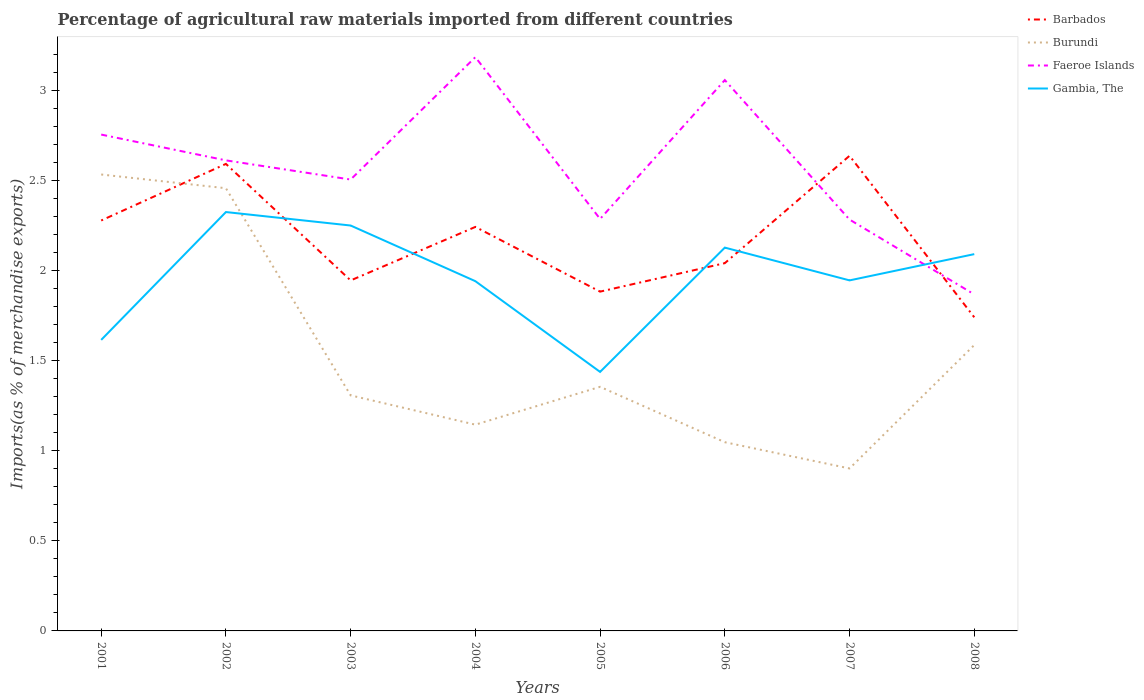Does the line corresponding to Barbados intersect with the line corresponding to Faeroe Islands?
Give a very brief answer. Yes. Is the number of lines equal to the number of legend labels?
Offer a very short reply. Yes. Across all years, what is the maximum percentage of imports to different countries in Burundi?
Your response must be concise. 0.9. What is the total percentage of imports to different countries in Gambia, The in the graph?
Ensure brevity in your answer.  -0.19. What is the difference between the highest and the second highest percentage of imports to different countries in Gambia, The?
Your answer should be very brief. 0.89. Is the percentage of imports to different countries in Faeroe Islands strictly greater than the percentage of imports to different countries in Barbados over the years?
Your response must be concise. No. How many lines are there?
Your answer should be very brief. 4. How many years are there in the graph?
Your response must be concise. 8. Are the values on the major ticks of Y-axis written in scientific E-notation?
Provide a short and direct response. No. Does the graph contain any zero values?
Provide a succinct answer. No. Does the graph contain grids?
Your answer should be very brief. No. How are the legend labels stacked?
Keep it short and to the point. Vertical. What is the title of the graph?
Ensure brevity in your answer.  Percentage of agricultural raw materials imported from different countries. What is the label or title of the X-axis?
Provide a succinct answer. Years. What is the label or title of the Y-axis?
Give a very brief answer. Imports(as % of merchandise exports). What is the Imports(as % of merchandise exports) in Barbados in 2001?
Make the answer very short. 2.28. What is the Imports(as % of merchandise exports) in Burundi in 2001?
Your response must be concise. 2.53. What is the Imports(as % of merchandise exports) of Faeroe Islands in 2001?
Keep it short and to the point. 2.75. What is the Imports(as % of merchandise exports) in Gambia, The in 2001?
Offer a terse response. 1.61. What is the Imports(as % of merchandise exports) in Barbados in 2002?
Offer a very short reply. 2.59. What is the Imports(as % of merchandise exports) in Burundi in 2002?
Make the answer very short. 2.46. What is the Imports(as % of merchandise exports) in Faeroe Islands in 2002?
Offer a very short reply. 2.61. What is the Imports(as % of merchandise exports) of Gambia, The in 2002?
Make the answer very short. 2.32. What is the Imports(as % of merchandise exports) of Barbados in 2003?
Provide a succinct answer. 1.94. What is the Imports(as % of merchandise exports) of Burundi in 2003?
Keep it short and to the point. 1.31. What is the Imports(as % of merchandise exports) in Faeroe Islands in 2003?
Your answer should be compact. 2.5. What is the Imports(as % of merchandise exports) of Gambia, The in 2003?
Your answer should be compact. 2.25. What is the Imports(as % of merchandise exports) of Barbados in 2004?
Provide a short and direct response. 2.24. What is the Imports(as % of merchandise exports) in Burundi in 2004?
Provide a succinct answer. 1.14. What is the Imports(as % of merchandise exports) in Faeroe Islands in 2004?
Your answer should be very brief. 3.18. What is the Imports(as % of merchandise exports) of Gambia, The in 2004?
Provide a succinct answer. 1.94. What is the Imports(as % of merchandise exports) of Barbados in 2005?
Ensure brevity in your answer.  1.88. What is the Imports(as % of merchandise exports) of Burundi in 2005?
Give a very brief answer. 1.35. What is the Imports(as % of merchandise exports) of Faeroe Islands in 2005?
Provide a succinct answer. 2.29. What is the Imports(as % of merchandise exports) of Gambia, The in 2005?
Offer a very short reply. 1.44. What is the Imports(as % of merchandise exports) of Barbados in 2006?
Your answer should be very brief. 2.04. What is the Imports(as % of merchandise exports) of Burundi in 2006?
Your answer should be compact. 1.05. What is the Imports(as % of merchandise exports) in Faeroe Islands in 2006?
Make the answer very short. 3.06. What is the Imports(as % of merchandise exports) of Gambia, The in 2006?
Provide a succinct answer. 2.13. What is the Imports(as % of merchandise exports) in Barbados in 2007?
Provide a short and direct response. 2.64. What is the Imports(as % of merchandise exports) of Burundi in 2007?
Offer a very short reply. 0.9. What is the Imports(as % of merchandise exports) in Faeroe Islands in 2007?
Keep it short and to the point. 2.28. What is the Imports(as % of merchandise exports) in Gambia, The in 2007?
Ensure brevity in your answer.  1.94. What is the Imports(as % of merchandise exports) in Barbados in 2008?
Keep it short and to the point. 1.74. What is the Imports(as % of merchandise exports) of Burundi in 2008?
Make the answer very short. 1.59. What is the Imports(as % of merchandise exports) in Faeroe Islands in 2008?
Provide a succinct answer. 1.87. What is the Imports(as % of merchandise exports) of Gambia, The in 2008?
Offer a very short reply. 2.09. Across all years, what is the maximum Imports(as % of merchandise exports) of Barbados?
Offer a very short reply. 2.64. Across all years, what is the maximum Imports(as % of merchandise exports) in Burundi?
Make the answer very short. 2.53. Across all years, what is the maximum Imports(as % of merchandise exports) in Faeroe Islands?
Your response must be concise. 3.18. Across all years, what is the maximum Imports(as % of merchandise exports) of Gambia, The?
Give a very brief answer. 2.32. Across all years, what is the minimum Imports(as % of merchandise exports) of Barbados?
Your response must be concise. 1.74. Across all years, what is the minimum Imports(as % of merchandise exports) in Burundi?
Ensure brevity in your answer.  0.9. Across all years, what is the minimum Imports(as % of merchandise exports) in Faeroe Islands?
Ensure brevity in your answer.  1.87. Across all years, what is the minimum Imports(as % of merchandise exports) of Gambia, The?
Your answer should be compact. 1.44. What is the total Imports(as % of merchandise exports) in Barbados in the graph?
Offer a terse response. 17.35. What is the total Imports(as % of merchandise exports) in Burundi in the graph?
Give a very brief answer. 12.33. What is the total Imports(as % of merchandise exports) of Faeroe Islands in the graph?
Offer a very short reply. 20.54. What is the total Imports(as % of merchandise exports) of Gambia, The in the graph?
Your response must be concise. 15.72. What is the difference between the Imports(as % of merchandise exports) of Barbados in 2001 and that in 2002?
Offer a terse response. -0.31. What is the difference between the Imports(as % of merchandise exports) in Burundi in 2001 and that in 2002?
Offer a terse response. 0.08. What is the difference between the Imports(as % of merchandise exports) of Faeroe Islands in 2001 and that in 2002?
Your answer should be very brief. 0.14. What is the difference between the Imports(as % of merchandise exports) in Gambia, The in 2001 and that in 2002?
Offer a very short reply. -0.71. What is the difference between the Imports(as % of merchandise exports) in Barbados in 2001 and that in 2003?
Make the answer very short. 0.33. What is the difference between the Imports(as % of merchandise exports) in Burundi in 2001 and that in 2003?
Your response must be concise. 1.23. What is the difference between the Imports(as % of merchandise exports) of Faeroe Islands in 2001 and that in 2003?
Provide a short and direct response. 0.25. What is the difference between the Imports(as % of merchandise exports) of Gambia, The in 2001 and that in 2003?
Provide a short and direct response. -0.63. What is the difference between the Imports(as % of merchandise exports) in Barbados in 2001 and that in 2004?
Your answer should be compact. 0.04. What is the difference between the Imports(as % of merchandise exports) in Burundi in 2001 and that in 2004?
Offer a terse response. 1.39. What is the difference between the Imports(as % of merchandise exports) in Faeroe Islands in 2001 and that in 2004?
Offer a terse response. -0.43. What is the difference between the Imports(as % of merchandise exports) in Gambia, The in 2001 and that in 2004?
Give a very brief answer. -0.33. What is the difference between the Imports(as % of merchandise exports) of Barbados in 2001 and that in 2005?
Give a very brief answer. 0.39. What is the difference between the Imports(as % of merchandise exports) of Burundi in 2001 and that in 2005?
Offer a very short reply. 1.18. What is the difference between the Imports(as % of merchandise exports) in Faeroe Islands in 2001 and that in 2005?
Give a very brief answer. 0.47. What is the difference between the Imports(as % of merchandise exports) of Gambia, The in 2001 and that in 2005?
Offer a very short reply. 0.18. What is the difference between the Imports(as % of merchandise exports) in Barbados in 2001 and that in 2006?
Offer a terse response. 0.24. What is the difference between the Imports(as % of merchandise exports) of Burundi in 2001 and that in 2006?
Your answer should be compact. 1.49. What is the difference between the Imports(as % of merchandise exports) of Faeroe Islands in 2001 and that in 2006?
Offer a terse response. -0.3. What is the difference between the Imports(as % of merchandise exports) of Gambia, The in 2001 and that in 2006?
Your response must be concise. -0.51. What is the difference between the Imports(as % of merchandise exports) of Barbados in 2001 and that in 2007?
Ensure brevity in your answer.  -0.36. What is the difference between the Imports(as % of merchandise exports) of Burundi in 2001 and that in 2007?
Provide a succinct answer. 1.63. What is the difference between the Imports(as % of merchandise exports) in Faeroe Islands in 2001 and that in 2007?
Your response must be concise. 0.47. What is the difference between the Imports(as % of merchandise exports) of Gambia, The in 2001 and that in 2007?
Ensure brevity in your answer.  -0.33. What is the difference between the Imports(as % of merchandise exports) of Barbados in 2001 and that in 2008?
Make the answer very short. 0.54. What is the difference between the Imports(as % of merchandise exports) in Burundi in 2001 and that in 2008?
Your answer should be compact. 0.95. What is the difference between the Imports(as % of merchandise exports) in Faeroe Islands in 2001 and that in 2008?
Keep it short and to the point. 0.89. What is the difference between the Imports(as % of merchandise exports) of Gambia, The in 2001 and that in 2008?
Provide a short and direct response. -0.48. What is the difference between the Imports(as % of merchandise exports) in Barbados in 2002 and that in 2003?
Ensure brevity in your answer.  0.65. What is the difference between the Imports(as % of merchandise exports) in Burundi in 2002 and that in 2003?
Make the answer very short. 1.15. What is the difference between the Imports(as % of merchandise exports) in Faeroe Islands in 2002 and that in 2003?
Your answer should be compact. 0.11. What is the difference between the Imports(as % of merchandise exports) of Gambia, The in 2002 and that in 2003?
Your response must be concise. 0.07. What is the difference between the Imports(as % of merchandise exports) in Barbados in 2002 and that in 2004?
Make the answer very short. 0.35. What is the difference between the Imports(as % of merchandise exports) in Burundi in 2002 and that in 2004?
Your response must be concise. 1.31. What is the difference between the Imports(as % of merchandise exports) of Faeroe Islands in 2002 and that in 2004?
Keep it short and to the point. -0.57. What is the difference between the Imports(as % of merchandise exports) of Gambia, The in 2002 and that in 2004?
Your answer should be very brief. 0.38. What is the difference between the Imports(as % of merchandise exports) of Barbados in 2002 and that in 2005?
Give a very brief answer. 0.71. What is the difference between the Imports(as % of merchandise exports) of Burundi in 2002 and that in 2005?
Provide a short and direct response. 1.1. What is the difference between the Imports(as % of merchandise exports) of Faeroe Islands in 2002 and that in 2005?
Make the answer very short. 0.32. What is the difference between the Imports(as % of merchandise exports) of Gambia, The in 2002 and that in 2005?
Offer a terse response. 0.89. What is the difference between the Imports(as % of merchandise exports) in Barbados in 2002 and that in 2006?
Your response must be concise. 0.55. What is the difference between the Imports(as % of merchandise exports) of Burundi in 2002 and that in 2006?
Ensure brevity in your answer.  1.41. What is the difference between the Imports(as % of merchandise exports) of Faeroe Islands in 2002 and that in 2006?
Provide a succinct answer. -0.45. What is the difference between the Imports(as % of merchandise exports) of Gambia, The in 2002 and that in 2006?
Make the answer very short. 0.2. What is the difference between the Imports(as % of merchandise exports) of Barbados in 2002 and that in 2007?
Provide a succinct answer. -0.04. What is the difference between the Imports(as % of merchandise exports) in Burundi in 2002 and that in 2007?
Your answer should be very brief. 1.55. What is the difference between the Imports(as % of merchandise exports) in Faeroe Islands in 2002 and that in 2007?
Provide a short and direct response. 0.33. What is the difference between the Imports(as % of merchandise exports) in Gambia, The in 2002 and that in 2007?
Your answer should be compact. 0.38. What is the difference between the Imports(as % of merchandise exports) in Barbados in 2002 and that in 2008?
Make the answer very short. 0.85. What is the difference between the Imports(as % of merchandise exports) of Burundi in 2002 and that in 2008?
Keep it short and to the point. 0.87. What is the difference between the Imports(as % of merchandise exports) of Faeroe Islands in 2002 and that in 2008?
Your response must be concise. 0.74. What is the difference between the Imports(as % of merchandise exports) of Gambia, The in 2002 and that in 2008?
Your answer should be compact. 0.23. What is the difference between the Imports(as % of merchandise exports) of Barbados in 2003 and that in 2004?
Provide a short and direct response. -0.3. What is the difference between the Imports(as % of merchandise exports) in Burundi in 2003 and that in 2004?
Your answer should be compact. 0.16. What is the difference between the Imports(as % of merchandise exports) in Faeroe Islands in 2003 and that in 2004?
Your response must be concise. -0.68. What is the difference between the Imports(as % of merchandise exports) in Gambia, The in 2003 and that in 2004?
Offer a very short reply. 0.31. What is the difference between the Imports(as % of merchandise exports) of Barbados in 2003 and that in 2005?
Give a very brief answer. 0.06. What is the difference between the Imports(as % of merchandise exports) of Burundi in 2003 and that in 2005?
Offer a very short reply. -0.05. What is the difference between the Imports(as % of merchandise exports) in Faeroe Islands in 2003 and that in 2005?
Provide a succinct answer. 0.22. What is the difference between the Imports(as % of merchandise exports) in Gambia, The in 2003 and that in 2005?
Provide a succinct answer. 0.81. What is the difference between the Imports(as % of merchandise exports) in Barbados in 2003 and that in 2006?
Your answer should be compact. -0.1. What is the difference between the Imports(as % of merchandise exports) in Burundi in 2003 and that in 2006?
Provide a succinct answer. 0.26. What is the difference between the Imports(as % of merchandise exports) of Faeroe Islands in 2003 and that in 2006?
Offer a very short reply. -0.55. What is the difference between the Imports(as % of merchandise exports) of Gambia, The in 2003 and that in 2006?
Your answer should be very brief. 0.12. What is the difference between the Imports(as % of merchandise exports) in Barbados in 2003 and that in 2007?
Offer a very short reply. -0.69. What is the difference between the Imports(as % of merchandise exports) in Burundi in 2003 and that in 2007?
Provide a short and direct response. 0.41. What is the difference between the Imports(as % of merchandise exports) in Faeroe Islands in 2003 and that in 2007?
Your answer should be very brief. 0.22. What is the difference between the Imports(as % of merchandise exports) in Gambia, The in 2003 and that in 2007?
Your answer should be very brief. 0.3. What is the difference between the Imports(as % of merchandise exports) in Barbados in 2003 and that in 2008?
Offer a very short reply. 0.2. What is the difference between the Imports(as % of merchandise exports) of Burundi in 2003 and that in 2008?
Your response must be concise. -0.28. What is the difference between the Imports(as % of merchandise exports) in Faeroe Islands in 2003 and that in 2008?
Your response must be concise. 0.64. What is the difference between the Imports(as % of merchandise exports) of Gambia, The in 2003 and that in 2008?
Your answer should be very brief. 0.16. What is the difference between the Imports(as % of merchandise exports) in Barbados in 2004 and that in 2005?
Give a very brief answer. 0.36. What is the difference between the Imports(as % of merchandise exports) of Burundi in 2004 and that in 2005?
Offer a very short reply. -0.21. What is the difference between the Imports(as % of merchandise exports) of Faeroe Islands in 2004 and that in 2005?
Keep it short and to the point. 0.9. What is the difference between the Imports(as % of merchandise exports) of Gambia, The in 2004 and that in 2005?
Make the answer very short. 0.5. What is the difference between the Imports(as % of merchandise exports) of Barbados in 2004 and that in 2006?
Provide a short and direct response. 0.2. What is the difference between the Imports(as % of merchandise exports) of Burundi in 2004 and that in 2006?
Make the answer very short. 0.1. What is the difference between the Imports(as % of merchandise exports) of Faeroe Islands in 2004 and that in 2006?
Your response must be concise. 0.13. What is the difference between the Imports(as % of merchandise exports) of Gambia, The in 2004 and that in 2006?
Make the answer very short. -0.19. What is the difference between the Imports(as % of merchandise exports) of Barbados in 2004 and that in 2007?
Keep it short and to the point. -0.39. What is the difference between the Imports(as % of merchandise exports) in Burundi in 2004 and that in 2007?
Provide a short and direct response. 0.24. What is the difference between the Imports(as % of merchandise exports) of Faeroe Islands in 2004 and that in 2007?
Make the answer very short. 0.9. What is the difference between the Imports(as % of merchandise exports) of Gambia, The in 2004 and that in 2007?
Make the answer very short. -0. What is the difference between the Imports(as % of merchandise exports) in Barbados in 2004 and that in 2008?
Ensure brevity in your answer.  0.5. What is the difference between the Imports(as % of merchandise exports) of Burundi in 2004 and that in 2008?
Offer a very short reply. -0.44. What is the difference between the Imports(as % of merchandise exports) in Faeroe Islands in 2004 and that in 2008?
Offer a terse response. 1.32. What is the difference between the Imports(as % of merchandise exports) of Gambia, The in 2004 and that in 2008?
Make the answer very short. -0.15. What is the difference between the Imports(as % of merchandise exports) in Barbados in 2005 and that in 2006?
Offer a terse response. -0.16. What is the difference between the Imports(as % of merchandise exports) of Burundi in 2005 and that in 2006?
Your response must be concise. 0.31. What is the difference between the Imports(as % of merchandise exports) in Faeroe Islands in 2005 and that in 2006?
Provide a short and direct response. -0.77. What is the difference between the Imports(as % of merchandise exports) of Gambia, The in 2005 and that in 2006?
Offer a terse response. -0.69. What is the difference between the Imports(as % of merchandise exports) of Barbados in 2005 and that in 2007?
Your answer should be very brief. -0.75. What is the difference between the Imports(as % of merchandise exports) in Burundi in 2005 and that in 2007?
Provide a short and direct response. 0.45. What is the difference between the Imports(as % of merchandise exports) of Faeroe Islands in 2005 and that in 2007?
Keep it short and to the point. 0. What is the difference between the Imports(as % of merchandise exports) in Gambia, The in 2005 and that in 2007?
Your response must be concise. -0.51. What is the difference between the Imports(as % of merchandise exports) of Barbados in 2005 and that in 2008?
Your answer should be very brief. 0.14. What is the difference between the Imports(as % of merchandise exports) in Burundi in 2005 and that in 2008?
Make the answer very short. -0.23. What is the difference between the Imports(as % of merchandise exports) in Faeroe Islands in 2005 and that in 2008?
Offer a very short reply. 0.42. What is the difference between the Imports(as % of merchandise exports) in Gambia, The in 2005 and that in 2008?
Provide a succinct answer. -0.65. What is the difference between the Imports(as % of merchandise exports) of Barbados in 2006 and that in 2007?
Your answer should be very brief. -0.6. What is the difference between the Imports(as % of merchandise exports) of Burundi in 2006 and that in 2007?
Give a very brief answer. 0.15. What is the difference between the Imports(as % of merchandise exports) in Faeroe Islands in 2006 and that in 2007?
Offer a terse response. 0.77. What is the difference between the Imports(as % of merchandise exports) in Gambia, The in 2006 and that in 2007?
Keep it short and to the point. 0.18. What is the difference between the Imports(as % of merchandise exports) in Barbados in 2006 and that in 2008?
Your answer should be compact. 0.3. What is the difference between the Imports(as % of merchandise exports) in Burundi in 2006 and that in 2008?
Give a very brief answer. -0.54. What is the difference between the Imports(as % of merchandise exports) of Faeroe Islands in 2006 and that in 2008?
Make the answer very short. 1.19. What is the difference between the Imports(as % of merchandise exports) in Gambia, The in 2006 and that in 2008?
Provide a succinct answer. 0.04. What is the difference between the Imports(as % of merchandise exports) of Barbados in 2007 and that in 2008?
Offer a terse response. 0.9. What is the difference between the Imports(as % of merchandise exports) in Burundi in 2007 and that in 2008?
Offer a very short reply. -0.68. What is the difference between the Imports(as % of merchandise exports) in Faeroe Islands in 2007 and that in 2008?
Give a very brief answer. 0.42. What is the difference between the Imports(as % of merchandise exports) of Gambia, The in 2007 and that in 2008?
Provide a succinct answer. -0.15. What is the difference between the Imports(as % of merchandise exports) of Barbados in 2001 and the Imports(as % of merchandise exports) of Burundi in 2002?
Your answer should be compact. -0.18. What is the difference between the Imports(as % of merchandise exports) in Barbados in 2001 and the Imports(as % of merchandise exports) in Faeroe Islands in 2002?
Keep it short and to the point. -0.33. What is the difference between the Imports(as % of merchandise exports) in Barbados in 2001 and the Imports(as % of merchandise exports) in Gambia, The in 2002?
Your answer should be very brief. -0.05. What is the difference between the Imports(as % of merchandise exports) in Burundi in 2001 and the Imports(as % of merchandise exports) in Faeroe Islands in 2002?
Your response must be concise. -0.08. What is the difference between the Imports(as % of merchandise exports) in Burundi in 2001 and the Imports(as % of merchandise exports) in Gambia, The in 2002?
Your answer should be very brief. 0.21. What is the difference between the Imports(as % of merchandise exports) of Faeroe Islands in 2001 and the Imports(as % of merchandise exports) of Gambia, The in 2002?
Provide a short and direct response. 0.43. What is the difference between the Imports(as % of merchandise exports) of Barbados in 2001 and the Imports(as % of merchandise exports) of Burundi in 2003?
Give a very brief answer. 0.97. What is the difference between the Imports(as % of merchandise exports) of Barbados in 2001 and the Imports(as % of merchandise exports) of Faeroe Islands in 2003?
Your answer should be compact. -0.23. What is the difference between the Imports(as % of merchandise exports) of Barbados in 2001 and the Imports(as % of merchandise exports) of Gambia, The in 2003?
Offer a terse response. 0.03. What is the difference between the Imports(as % of merchandise exports) of Burundi in 2001 and the Imports(as % of merchandise exports) of Faeroe Islands in 2003?
Provide a short and direct response. 0.03. What is the difference between the Imports(as % of merchandise exports) of Burundi in 2001 and the Imports(as % of merchandise exports) of Gambia, The in 2003?
Your response must be concise. 0.28. What is the difference between the Imports(as % of merchandise exports) of Faeroe Islands in 2001 and the Imports(as % of merchandise exports) of Gambia, The in 2003?
Make the answer very short. 0.5. What is the difference between the Imports(as % of merchandise exports) of Barbados in 2001 and the Imports(as % of merchandise exports) of Burundi in 2004?
Offer a very short reply. 1.13. What is the difference between the Imports(as % of merchandise exports) of Barbados in 2001 and the Imports(as % of merchandise exports) of Faeroe Islands in 2004?
Provide a short and direct response. -0.91. What is the difference between the Imports(as % of merchandise exports) in Barbados in 2001 and the Imports(as % of merchandise exports) in Gambia, The in 2004?
Your answer should be very brief. 0.34. What is the difference between the Imports(as % of merchandise exports) in Burundi in 2001 and the Imports(as % of merchandise exports) in Faeroe Islands in 2004?
Keep it short and to the point. -0.65. What is the difference between the Imports(as % of merchandise exports) in Burundi in 2001 and the Imports(as % of merchandise exports) in Gambia, The in 2004?
Provide a succinct answer. 0.59. What is the difference between the Imports(as % of merchandise exports) of Faeroe Islands in 2001 and the Imports(as % of merchandise exports) of Gambia, The in 2004?
Provide a succinct answer. 0.81. What is the difference between the Imports(as % of merchandise exports) in Barbados in 2001 and the Imports(as % of merchandise exports) in Burundi in 2005?
Your response must be concise. 0.92. What is the difference between the Imports(as % of merchandise exports) of Barbados in 2001 and the Imports(as % of merchandise exports) of Faeroe Islands in 2005?
Provide a succinct answer. -0.01. What is the difference between the Imports(as % of merchandise exports) in Barbados in 2001 and the Imports(as % of merchandise exports) in Gambia, The in 2005?
Provide a succinct answer. 0.84. What is the difference between the Imports(as % of merchandise exports) of Burundi in 2001 and the Imports(as % of merchandise exports) of Faeroe Islands in 2005?
Give a very brief answer. 0.25. What is the difference between the Imports(as % of merchandise exports) of Burundi in 2001 and the Imports(as % of merchandise exports) of Gambia, The in 2005?
Your response must be concise. 1.1. What is the difference between the Imports(as % of merchandise exports) of Faeroe Islands in 2001 and the Imports(as % of merchandise exports) of Gambia, The in 2005?
Ensure brevity in your answer.  1.32. What is the difference between the Imports(as % of merchandise exports) of Barbados in 2001 and the Imports(as % of merchandise exports) of Burundi in 2006?
Your answer should be compact. 1.23. What is the difference between the Imports(as % of merchandise exports) of Barbados in 2001 and the Imports(as % of merchandise exports) of Faeroe Islands in 2006?
Make the answer very short. -0.78. What is the difference between the Imports(as % of merchandise exports) of Barbados in 2001 and the Imports(as % of merchandise exports) of Gambia, The in 2006?
Provide a succinct answer. 0.15. What is the difference between the Imports(as % of merchandise exports) in Burundi in 2001 and the Imports(as % of merchandise exports) in Faeroe Islands in 2006?
Ensure brevity in your answer.  -0.52. What is the difference between the Imports(as % of merchandise exports) of Burundi in 2001 and the Imports(as % of merchandise exports) of Gambia, The in 2006?
Offer a terse response. 0.41. What is the difference between the Imports(as % of merchandise exports) of Faeroe Islands in 2001 and the Imports(as % of merchandise exports) of Gambia, The in 2006?
Offer a terse response. 0.63. What is the difference between the Imports(as % of merchandise exports) in Barbados in 2001 and the Imports(as % of merchandise exports) in Burundi in 2007?
Provide a short and direct response. 1.38. What is the difference between the Imports(as % of merchandise exports) of Barbados in 2001 and the Imports(as % of merchandise exports) of Faeroe Islands in 2007?
Provide a succinct answer. -0.01. What is the difference between the Imports(as % of merchandise exports) in Barbados in 2001 and the Imports(as % of merchandise exports) in Gambia, The in 2007?
Offer a very short reply. 0.33. What is the difference between the Imports(as % of merchandise exports) of Burundi in 2001 and the Imports(as % of merchandise exports) of Faeroe Islands in 2007?
Offer a terse response. 0.25. What is the difference between the Imports(as % of merchandise exports) in Burundi in 2001 and the Imports(as % of merchandise exports) in Gambia, The in 2007?
Your answer should be very brief. 0.59. What is the difference between the Imports(as % of merchandise exports) of Faeroe Islands in 2001 and the Imports(as % of merchandise exports) of Gambia, The in 2007?
Ensure brevity in your answer.  0.81. What is the difference between the Imports(as % of merchandise exports) of Barbados in 2001 and the Imports(as % of merchandise exports) of Burundi in 2008?
Your answer should be very brief. 0.69. What is the difference between the Imports(as % of merchandise exports) in Barbados in 2001 and the Imports(as % of merchandise exports) in Faeroe Islands in 2008?
Offer a very short reply. 0.41. What is the difference between the Imports(as % of merchandise exports) in Barbados in 2001 and the Imports(as % of merchandise exports) in Gambia, The in 2008?
Your answer should be compact. 0.19. What is the difference between the Imports(as % of merchandise exports) in Burundi in 2001 and the Imports(as % of merchandise exports) in Faeroe Islands in 2008?
Give a very brief answer. 0.67. What is the difference between the Imports(as % of merchandise exports) of Burundi in 2001 and the Imports(as % of merchandise exports) of Gambia, The in 2008?
Give a very brief answer. 0.44. What is the difference between the Imports(as % of merchandise exports) in Faeroe Islands in 2001 and the Imports(as % of merchandise exports) in Gambia, The in 2008?
Ensure brevity in your answer.  0.66. What is the difference between the Imports(as % of merchandise exports) in Barbados in 2002 and the Imports(as % of merchandise exports) in Burundi in 2003?
Provide a short and direct response. 1.28. What is the difference between the Imports(as % of merchandise exports) of Barbados in 2002 and the Imports(as % of merchandise exports) of Faeroe Islands in 2003?
Provide a succinct answer. 0.09. What is the difference between the Imports(as % of merchandise exports) in Barbados in 2002 and the Imports(as % of merchandise exports) in Gambia, The in 2003?
Offer a terse response. 0.34. What is the difference between the Imports(as % of merchandise exports) of Burundi in 2002 and the Imports(as % of merchandise exports) of Faeroe Islands in 2003?
Your answer should be compact. -0.05. What is the difference between the Imports(as % of merchandise exports) in Burundi in 2002 and the Imports(as % of merchandise exports) in Gambia, The in 2003?
Ensure brevity in your answer.  0.21. What is the difference between the Imports(as % of merchandise exports) of Faeroe Islands in 2002 and the Imports(as % of merchandise exports) of Gambia, The in 2003?
Your answer should be very brief. 0.36. What is the difference between the Imports(as % of merchandise exports) in Barbados in 2002 and the Imports(as % of merchandise exports) in Burundi in 2004?
Your response must be concise. 1.45. What is the difference between the Imports(as % of merchandise exports) in Barbados in 2002 and the Imports(as % of merchandise exports) in Faeroe Islands in 2004?
Your answer should be very brief. -0.59. What is the difference between the Imports(as % of merchandise exports) of Barbados in 2002 and the Imports(as % of merchandise exports) of Gambia, The in 2004?
Your response must be concise. 0.65. What is the difference between the Imports(as % of merchandise exports) in Burundi in 2002 and the Imports(as % of merchandise exports) in Faeroe Islands in 2004?
Make the answer very short. -0.73. What is the difference between the Imports(as % of merchandise exports) of Burundi in 2002 and the Imports(as % of merchandise exports) of Gambia, The in 2004?
Your response must be concise. 0.52. What is the difference between the Imports(as % of merchandise exports) in Faeroe Islands in 2002 and the Imports(as % of merchandise exports) in Gambia, The in 2004?
Keep it short and to the point. 0.67. What is the difference between the Imports(as % of merchandise exports) of Barbados in 2002 and the Imports(as % of merchandise exports) of Burundi in 2005?
Keep it short and to the point. 1.24. What is the difference between the Imports(as % of merchandise exports) in Barbados in 2002 and the Imports(as % of merchandise exports) in Faeroe Islands in 2005?
Make the answer very short. 0.31. What is the difference between the Imports(as % of merchandise exports) of Barbados in 2002 and the Imports(as % of merchandise exports) of Gambia, The in 2005?
Your answer should be compact. 1.15. What is the difference between the Imports(as % of merchandise exports) in Burundi in 2002 and the Imports(as % of merchandise exports) in Faeroe Islands in 2005?
Offer a terse response. 0.17. What is the difference between the Imports(as % of merchandise exports) of Burundi in 2002 and the Imports(as % of merchandise exports) of Gambia, The in 2005?
Give a very brief answer. 1.02. What is the difference between the Imports(as % of merchandise exports) in Faeroe Islands in 2002 and the Imports(as % of merchandise exports) in Gambia, The in 2005?
Offer a very short reply. 1.17. What is the difference between the Imports(as % of merchandise exports) in Barbados in 2002 and the Imports(as % of merchandise exports) in Burundi in 2006?
Provide a succinct answer. 1.54. What is the difference between the Imports(as % of merchandise exports) in Barbados in 2002 and the Imports(as % of merchandise exports) in Faeroe Islands in 2006?
Your response must be concise. -0.46. What is the difference between the Imports(as % of merchandise exports) in Barbados in 2002 and the Imports(as % of merchandise exports) in Gambia, The in 2006?
Give a very brief answer. 0.46. What is the difference between the Imports(as % of merchandise exports) of Burundi in 2002 and the Imports(as % of merchandise exports) of Faeroe Islands in 2006?
Offer a terse response. -0.6. What is the difference between the Imports(as % of merchandise exports) of Burundi in 2002 and the Imports(as % of merchandise exports) of Gambia, The in 2006?
Give a very brief answer. 0.33. What is the difference between the Imports(as % of merchandise exports) in Faeroe Islands in 2002 and the Imports(as % of merchandise exports) in Gambia, The in 2006?
Keep it short and to the point. 0.48. What is the difference between the Imports(as % of merchandise exports) of Barbados in 2002 and the Imports(as % of merchandise exports) of Burundi in 2007?
Make the answer very short. 1.69. What is the difference between the Imports(as % of merchandise exports) of Barbados in 2002 and the Imports(as % of merchandise exports) of Faeroe Islands in 2007?
Your answer should be very brief. 0.31. What is the difference between the Imports(as % of merchandise exports) in Barbados in 2002 and the Imports(as % of merchandise exports) in Gambia, The in 2007?
Your response must be concise. 0.65. What is the difference between the Imports(as % of merchandise exports) in Burundi in 2002 and the Imports(as % of merchandise exports) in Faeroe Islands in 2007?
Offer a very short reply. 0.17. What is the difference between the Imports(as % of merchandise exports) in Burundi in 2002 and the Imports(as % of merchandise exports) in Gambia, The in 2007?
Provide a short and direct response. 0.51. What is the difference between the Imports(as % of merchandise exports) in Faeroe Islands in 2002 and the Imports(as % of merchandise exports) in Gambia, The in 2007?
Give a very brief answer. 0.67. What is the difference between the Imports(as % of merchandise exports) in Barbados in 2002 and the Imports(as % of merchandise exports) in Faeroe Islands in 2008?
Ensure brevity in your answer.  0.72. What is the difference between the Imports(as % of merchandise exports) of Barbados in 2002 and the Imports(as % of merchandise exports) of Gambia, The in 2008?
Keep it short and to the point. 0.5. What is the difference between the Imports(as % of merchandise exports) of Burundi in 2002 and the Imports(as % of merchandise exports) of Faeroe Islands in 2008?
Ensure brevity in your answer.  0.59. What is the difference between the Imports(as % of merchandise exports) in Burundi in 2002 and the Imports(as % of merchandise exports) in Gambia, The in 2008?
Keep it short and to the point. 0.37. What is the difference between the Imports(as % of merchandise exports) of Faeroe Islands in 2002 and the Imports(as % of merchandise exports) of Gambia, The in 2008?
Provide a succinct answer. 0.52. What is the difference between the Imports(as % of merchandise exports) of Barbados in 2003 and the Imports(as % of merchandise exports) of Burundi in 2004?
Your answer should be compact. 0.8. What is the difference between the Imports(as % of merchandise exports) in Barbados in 2003 and the Imports(as % of merchandise exports) in Faeroe Islands in 2004?
Make the answer very short. -1.24. What is the difference between the Imports(as % of merchandise exports) in Barbados in 2003 and the Imports(as % of merchandise exports) in Gambia, The in 2004?
Keep it short and to the point. 0. What is the difference between the Imports(as % of merchandise exports) in Burundi in 2003 and the Imports(as % of merchandise exports) in Faeroe Islands in 2004?
Offer a very short reply. -1.88. What is the difference between the Imports(as % of merchandise exports) of Burundi in 2003 and the Imports(as % of merchandise exports) of Gambia, The in 2004?
Keep it short and to the point. -0.63. What is the difference between the Imports(as % of merchandise exports) in Faeroe Islands in 2003 and the Imports(as % of merchandise exports) in Gambia, The in 2004?
Ensure brevity in your answer.  0.56. What is the difference between the Imports(as % of merchandise exports) of Barbados in 2003 and the Imports(as % of merchandise exports) of Burundi in 2005?
Offer a terse response. 0.59. What is the difference between the Imports(as % of merchandise exports) in Barbados in 2003 and the Imports(as % of merchandise exports) in Faeroe Islands in 2005?
Your answer should be compact. -0.34. What is the difference between the Imports(as % of merchandise exports) in Barbados in 2003 and the Imports(as % of merchandise exports) in Gambia, The in 2005?
Make the answer very short. 0.51. What is the difference between the Imports(as % of merchandise exports) in Burundi in 2003 and the Imports(as % of merchandise exports) in Faeroe Islands in 2005?
Give a very brief answer. -0.98. What is the difference between the Imports(as % of merchandise exports) in Burundi in 2003 and the Imports(as % of merchandise exports) in Gambia, The in 2005?
Provide a succinct answer. -0.13. What is the difference between the Imports(as % of merchandise exports) in Faeroe Islands in 2003 and the Imports(as % of merchandise exports) in Gambia, The in 2005?
Make the answer very short. 1.07. What is the difference between the Imports(as % of merchandise exports) in Barbados in 2003 and the Imports(as % of merchandise exports) in Burundi in 2006?
Your answer should be compact. 0.9. What is the difference between the Imports(as % of merchandise exports) of Barbados in 2003 and the Imports(as % of merchandise exports) of Faeroe Islands in 2006?
Make the answer very short. -1.11. What is the difference between the Imports(as % of merchandise exports) in Barbados in 2003 and the Imports(as % of merchandise exports) in Gambia, The in 2006?
Give a very brief answer. -0.18. What is the difference between the Imports(as % of merchandise exports) of Burundi in 2003 and the Imports(as % of merchandise exports) of Faeroe Islands in 2006?
Your answer should be very brief. -1.75. What is the difference between the Imports(as % of merchandise exports) in Burundi in 2003 and the Imports(as % of merchandise exports) in Gambia, The in 2006?
Your response must be concise. -0.82. What is the difference between the Imports(as % of merchandise exports) of Faeroe Islands in 2003 and the Imports(as % of merchandise exports) of Gambia, The in 2006?
Give a very brief answer. 0.38. What is the difference between the Imports(as % of merchandise exports) of Barbados in 2003 and the Imports(as % of merchandise exports) of Burundi in 2007?
Give a very brief answer. 1.04. What is the difference between the Imports(as % of merchandise exports) of Barbados in 2003 and the Imports(as % of merchandise exports) of Faeroe Islands in 2007?
Make the answer very short. -0.34. What is the difference between the Imports(as % of merchandise exports) of Barbados in 2003 and the Imports(as % of merchandise exports) of Gambia, The in 2007?
Give a very brief answer. -0. What is the difference between the Imports(as % of merchandise exports) in Burundi in 2003 and the Imports(as % of merchandise exports) in Faeroe Islands in 2007?
Offer a terse response. -0.98. What is the difference between the Imports(as % of merchandise exports) of Burundi in 2003 and the Imports(as % of merchandise exports) of Gambia, The in 2007?
Provide a short and direct response. -0.64. What is the difference between the Imports(as % of merchandise exports) of Faeroe Islands in 2003 and the Imports(as % of merchandise exports) of Gambia, The in 2007?
Keep it short and to the point. 0.56. What is the difference between the Imports(as % of merchandise exports) of Barbados in 2003 and the Imports(as % of merchandise exports) of Burundi in 2008?
Your response must be concise. 0.36. What is the difference between the Imports(as % of merchandise exports) in Barbados in 2003 and the Imports(as % of merchandise exports) in Faeroe Islands in 2008?
Provide a succinct answer. 0.08. What is the difference between the Imports(as % of merchandise exports) of Barbados in 2003 and the Imports(as % of merchandise exports) of Gambia, The in 2008?
Your answer should be very brief. -0.15. What is the difference between the Imports(as % of merchandise exports) of Burundi in 2003 and the Imports(as % of merchandise exports) of Faeroe Islands in 2008?
Offer a terse response. -0.56. What is the difference between the Imports(as % of merchandise exports) of Burundi in 2003 and the Imports(as % of merchandise exports) of Gambia, The in 2008?
Offer a very short reply. -0.78. What is the difference between the Imports(as % of merchandise exports) in Faeroe Islands in 2003 and the Imports(as % of merchandise exports) in Gambia, The in 2008?
Your answer should be compact. 0.41. What is the difference between the Imports(as % of merchandise exports) of Barbados in 2004 and the Imports(as % of merchandise exports) of Burundi in 2005?
Your answer should be compact. 0.89. What is the difference between the Imports(as % of merchandise exports) in Barbados in 2004 and the Imports(as % of merchandise exports) in Faeroe Islands in 2005?
Give a very brief answer. -0.04. What is the difference between the Imports(as % of merchandise exports) in Barbados in 2004 and the Imports(as % of merchandise exports) in Gambia, The in 2005?
Provide a succinct answer. 0.8. What is the difference between the Imports(as % of merchandise exports) of Burundi in 2004 and the Imports(as % of merchandise exports) of Faeroe Islands in 2005?
Provide a succinct answer. -1.14. What is the difference between the Imports(as % of merchandise exports) of Burundi in 2004 and the Imports(as % of merchandise exports) of Gambia, The in 2005?
Your answer should be very brief. -0.29. What is the difference between the Imports(as % of merchandise exports) of Faeroe Islands in 2004 and the Imports(as % of merchandise exports) of Gambia, The in 2005?
Give a very brief answer. 1.75. What is the difference between the Imports(as % of merchandise exports) of Barbados in 2004 and the Imports(as % of merchandise exports) of Burundi in 2006?
Offer a very short reply. 1.19. What is the difference between the Imports(as % of merchandise exports) of Barbados in 2004 and the Imports(as % of merchandise exports) of Faeroe Islands in 2006?
Provide a succinct answer. -0.81. What is the difference between the Imports(as % of merchandise exports) in Barbados in 2004 and the Imports(as % of merchandise exports) in Gambia, The in 2006?
Your answer should be compact. 0.11. What is the difference between the Imports(as % of merchandise exports) of Burundi in 2004 and the Imports(as % of merchandise exports) of Faeroe Islands in 2006?
Your answer should be compact. -1.91. What is the difference between the Imports(as % of merchandise exports) of Burundi in 2004 and the Imports(as % of merchandise exports) of Gambia, The in 2006?
Offer a terse response. -0.98. What is the difference between the Imports(as % of merchandise exports) of Faeroe Islands in 2004 and the Imports(as % of merchandise exports) of Gambia, The in 2006?
Offer a very short reply. 1.06. What is the difference between the Imports(as % of merchandise exports) of Barbados in 2004 and the Imports(as % of merchandise exports) of Burundi in 2007?
Ensure brevity in your answer.  1.34. What is the difference between the Imports(as % of merchandise exports) of Barbados in 2004 and the Imports(as % of merchandise exports) of Faeroe Islands in 2007?
Make the answer very short. -0.04. What is the difference between the Imports(as % of merchandise exports) of Barbados in 2004 and the Imports(as % of merchandise exports) of Gambia, The in 2007?
Your answer should be very brief. 0.3. What is the difference between the Imports(as % of merchandise exports) in Burundi in 2004 and the Imports(as % of merchandise exports) in Faeroe Islands in 2007?
Your answer should be compact. -1.14. What is the difference between the Imports(as % of merchandise exports) of Burundi in 2004 and the Imports(as % of merchandise exports) of Gambia, The in 2007?
Give a very brief answer. -0.8. What is the difference between the Imports(as % of merchandise exports) in Faeroe Islands in 2004 and the Imports(as % of merchandise exports) in Gambia, The in 2007?
Provide a short and direct response. 1.24. What is the difference between the Imports(as % of merchandise exports) of Barbados in 2004 and the Imports(as % of merchandise exports) of Burundi in 2008?
Your answer should be very brief. 0.66. What is the difference between the Imports(as % of merchandise exports) of Barbados in 2004 and the Imports(as % of merchandise exports) of Faeroe Islands in 2008?
Keep it short and to the point. 0.37. What is the difference between the Imports(as % of merchandise exports) in Barbados in 2004 and the Imports(as % of merchandise exports) in Gambia, The in 2008?
Offer a terse response. 0.15. What is the difference between the Imports(as % of merchandise exports) in Burundi in 2004 and the Imports(as % of merchandise exports) in Faeroe Islands in 2008?
Provide a succinct answer. -0.72. What is the difference between the Imports(as % of merchandise exports) of Burundi in 2004 and the Imports(as % of merchandise exports) of Gambia, The in 2008?
Ensure brevity in your answer.  -0.95. What is the difference between the Imports(as % of merchandise exports) in Faeroe Islands in 2004 and the Imports(as % of merchandise exports) in Gambia, The in 2008?
Keep it short and to the point. 1.09. What is the difference between the Imports(as % of merchandise exports) of Barbados in 2005 and the Imports(as % of merchandise exports) of Burundi in 2006?
Offer a terse response. 0.84. What is the difference between the Imports(as % of merchandise exports) of Barbados in 2005 and the Imports(as % of merchandise exports) of Faeroe Islands in 2006?
Your answer should be very brief. -1.17. What is the difference between the Imports(as % of merchandise exports) in Barbados in 2005 and the Imports(as % of merchandise exports) in Gambia, The in 2006?
Offer a very short reply. -0.24. What is the difference between the Imports(as % of merchandise exports) in Burundi in 2005 and the Imports(as % of merchandise exports) in Faeroe Islands in 2006?
Keep it short and to the point. -1.7. What is the difference between the Imports(as % of merchandise exports) of Burundi in 2005 and the Imports(as % of merchandise exports) of Gambia, The in 2006?
Give a very brief answer. -0.77. What is the difference between the Imports(as % of merchandise exports) of Faeroe Islands in 2005 and the Imports(as % of merchandise exports) of Gambia, The in 2006?
Offer a terse response. 0.16. What is the difference between the Imports(as % of merchandise exports) of Barbados in 2005 and the Imports(as % of merchandise exports) of Burundi in 2007?
Your response must be concise. 0.98. What is the difference between the Imports(as % of merchandise exports) of Barbados in 2005 and the Imports(as % of merchandise exports) of Faeroe Islands in 2007?
Your answer should be very brief. -0.4. What is the difference between the Imports(as % of merchandise exports) of Barbados in 2005 and the Imports(as % of merchandise exports) of Gambia, The in 2007?
Keep it short and to the point. -0.06. What is the difference between the Imports(as % of merchandise exports) of Burundi in 2005 and the Imports(as % of merchandise exports) of Faeroe Islands in 2007?
Keep it short and to the point. -0.93. What is the difference between the Imports(as % of merchandise exports) of Burundi in 2005 and the Imports(as % of merchandise exports) of Gambia, The in 2007?
Your response must be concise. -0.59. What is the difference between the Imports(as % of merchandise exports) of Faeroe Islands in 2005 and the Imports(as % of merchandise exports) of Gambia, The in 2007?
Make the answer very short. 0.34. What is the difference between the Imports(as % of merchandise exports) in Barbados in 2005 and the Imports(as % of merchandise exports) in Burundi in 2008?
Offer a terse response. 0.3. What is the difference between the Imports(as % of merchandise exports) of Barbados in 2005 and the Imports(as % of merchandise exports) of Faeroe Islands in 2008?
Give a very brief answer. 0.02. What is the difference between the Imports(as % of merchandise exports) of Barbados in 2005 and the Imports(as % of merchandise exports) of Gambia, The in 2008?
Provide a succinct answer. -0.21. What is the difference between the Imports(as % of merchandise exports) in Burundi in 2005 and the Imports(as % of merchandise exports) in Faeroe Islands in 2008?
Make the answer very short. -0.51. What is the difference between the Imports(as % of merchandise exports) of Burundi in 2005 and the Imports(as % of merchandise exports) of Gambia, The in 2008?
Your answer should be compact. -0.74. What is the difference between the Imports(as % of merchandise exports) in Faeroe Islands in 2005 and the Imports(as % of merchandise exports) in Gambia, The in 2008?
Give a very brief answer. 0.2. What is the difference between the Imports(as % of merchandise exports) of Barbados in 2006 and the Imports(as % of merchandise exports) of Burundi in 2007?
Offer a terse response. 1.14. What is the difference between the Imports(as % of merchandise exports) of Barbados in 2006 and the Imports(as % of merchandise exports) of Faeroe Islands in 2007?
Keep it short and to the point. -0.24. What is the difference between the Imports(as % of merchandise exports) in Barbados in 2006 and the Imports(as % of merchandise exports) in Gambia, The in 2007?
Your answer should be compact. 0.1. What is the difference between the Imports(as % of merchandise exports) in Burundi in 2006 and the Imports(as % of merchandise exports) in Faeroe Islands in 2007?
Your response must be concise. -1.24. What is the difference between the Imports(as % of merchandise exports) in Burundi in 2006 and the Imports(as % of merchandise exports) in Gambia, The in 2007?
Give a very brief answer. -0.9. What is the difference between the Imports(as % of merchandise exports) in Faeroe Islands in 2006 and the Imports(as % of merchandise exports) in Gambia, The in 2007?
Offer a terse response. 1.11. What is the difference between the Imports(as % of merchandise exports) of Barbados in 2006 and the Imports(as % of merchandise exports) of Burundi in 2008?
Keep it short and to the point. 0.45. What is the difference between the Imports(as % of merchandise exports) in Barbados in 2006 and the Imports(as % of merchandise exports) in Faeroe Islands in 2008?
Provide a succinct answer. 0.17. What is the difference between the Imports(as % of merchandise exports) in Barbados in 2006 and the Imports(as % of merchandise exports) in Gambia, The in 2008?
Your response must be concise. -0.05. What is the difference between the Imports(as % of merchandise exports) of Burundi in 2006 and the Imports(as % of merchandise exports) of Faeroe Islands in 2008?
Offer a terse response. -0.82. What is the difference between the Imports(as % of merchandise exports) in Burundi in 2006 and the Imports(as % of merchandise exports) in Gambia, The in 2008?
Provide a succinct answer. -1.04. What is the difference between the Imports(as % of merchandise exports) in Faeroe Islands in 2006 and the Imports(as % of merchandise exports) in Gambia, The in 2008?
Provide a succinct answer. 0.97. What is the difference between the Imports(as % of merchandise exports) in Barbados in 2007 and the Imports(as % of merchandise exports) in Burundi in 2008?
Give a very brief answer. 1.05. What is the difference between the Imports(as % of merchandise exports) in Barbados in 2007 and the Imports(as % of merchandise exports) in Faeroe Islands in 2008?
Your response must be concise. 0.77. What is the difference between the Imports(as % of merchandise exports) in Barbados in 2007 and the Imports(as % of merchandise exports) in Gambia, The in 2008?
Offer a very short reply. 0.55. What is the difference between the Imports(as % of merchandise exports) in Burundi in 2007 and the Imports(as % of merchandise exports) in Faeroe Islands in 2008?
Give a very brief answer. -0.97. What is the difference between the Imports(as % of merchandise exports) of Burundi in 2007 and the Imports(as % of merchandise exports) of Gambia, The in 2008?
Your answer should be very brief. -1.19. What is the difference between the Imports(as % of merchandise exports) of Faeroe Islands in 2007 and the Imports(as % of merchandise exports) of Gambia, The in 2008?
Your answer should be very brief. 0.19. What is the average Imports(as % of merchandise exports) of Barbados per year?
Your answer should be compact. 2.17. What is the average Imports(as % of merchandise exports) in Burundi per year?
Provide a short and direct response. 1.54. What is the average Imports(as % of merchandise exports) in Faeroe Islands per year?
Your answer should be compact. 2.57. What is the average Imports(as % of merchandise exports) in Gambia, The per year?
Your response must be concise. 1.97. In the year 2001, what is the difference between the Imports(as % of merchandise exports) in Barbados and Imports(as % of merchandise exports) in Burundi?
Provide a short and direct response. -0.26. In the year 2001, what is the difference between the Imports(as % of merchandise exports) of Barbados and Imports(as % of merchandise exports) of Faeroe Islands?
Make the answer very short. -0.48. In the year 2001, what is the difference between the Imports(as % of merchandise exports) of Barbados and Imports(as % of merchandise exports) of Gambia, The?
Provide a succinct answer. 0.66. In the year 2001, what is the difference between the Imports(as % of merchandise exports) in Burundi and Imports(as % of merchandise exports) in Faeroe Islands?
Give a very brief answer. -0.22. In the year 2001, what is the difference between the Imports(as % of merchandise exports) of Burundi and Imports(as % of merchandise exports) of Gambia, The?
Provide a short and direct response. 0.92. In the year 2001, what is the difference between the Imports(as % of merchandise exports) in Faeroe Islands and Imports(as % of merchandise exports) in Gambia, The?
Provide a short and direct response. 1.14. In the year 2002, what is the difference between the Imports(as % of merchandise exports) in Barbados and Imports(as % of merchandise exports) in Burundi?
Offer a very short reply. 0.14. In the year 2002, what is the difference between the Imports(as % of merchandise exports) in Barbados and Imports(as % of merchandise exports) in Faeroe Islands?
Provide a short and direct response. -0.02. In the year 2002, what is the difference between the Imports(as % of merchandise exports) in Barbados and Imports(as % of merchandise exports) in Gambia, The?
Provide a succinct answer. 0.27. In the year 2002, what is the difference between the Imports(as % of merchandise exports) in Burundi and Imports(as % of merchandise exports) in Faeroe Islands?
Provide a short and direct response. -0.15. In the year 2002, what is the difference between the Imports(as % of merchandise exports) in Burundi and Imports(as % of merchandise exports) in Gambia, The?
Keep it short and to the point. 0.13. In the year 2002, what is the difference between the Imports(as % of merchandise exports) in Faeroe Islands and Imports(as % of merchandise exports) in Gambia, The?
Your answer should be very brief. 0.29. In the year 2003, what is the difference between the Imports(as % of merchandise exports) in Barbados and Imports(as % of merchandise exports) in Burundi?
Your response must be concise. 0.64. In the year 2003, what is the difference between the Imports(as % of merchandise exports) of Barbados and Imports(as % of merchandise exports) of Faeroe Islands?
Offer a terse response. -0.56. In the year 2003, what is the difference between the Imports(as % of merchandise exports) in Barbados and Imports(as % of merchandise exports) in Gambia, The?
Your response must be concise. -0.3. In the year 2003, what is the difference between the Imports(as % of merchandise exports) in Burundi and Imports(as % of merchandise exports) in Faeroe Islands?
Ensure brevity in your answer.  -1.2. In the year 2003, what is the difference between the Imports(as % of merchandise exports) in Burundi and Imports(as % of merchandise exports) in Gambia, The?
Give a very brief answer. -0.94. In the year 2003, what is the difference between the Imports(as % of merchandise exports) of Faeroe Islands and Imports(as % of merchandise exports) of Gambia, The?
Offer a very short reply. 0.26. In the year 2004, what is the difference between the Imports(as % of merchandise exports) of Barbados and Imports(as % of merchandise exports) of Burundi?
Offer a very short reply. 1.1. In the year 2004, what is the difference between the Imports(as % of merchandise exports) of Barbados and Imports(as % of merchandise exports) of Faeroe Islands?
Your answer should be very brief. -0.94. In the year 2004, what is the difference between the Imports(as % of merchandise exports) of Barbados and Imports(as % of merchandise exports) of Gambia, The?
Keep it short and to the point. 0.3. In the year 2004, what is the difference between the Imports(as % of merchandise exports) of Burundi and Imports(as % of merchandise exports) of Faeroe Islands?
Give a very brief answer. -2.04. In the year 2004, what is the difference between the Imports(as % of merchandise exports) of Burundi and Imports(as % of merchandise exports) of Gambia, The?
Offer a terse response. -0.8. In the year 2004, what is the difference between the Imports(as % of merchandise exports) of Faeroe Islands and Imports(as % of merchandise exports) of Gambia, The?
Keep it short and to the point. 1.24. In the year 2005, what is the difference between the Imports(as % of merchandise exports) of Barbados and Imports(as % of merchandise exports) of Burundi?
Provide a succinct answer. 0.53. In the year 2005, what is the difference between the Imports(as % of merchandise exports) in Barbados and Imports(as % of merchandise exports) in Faeroe Islands?
Provide a short and direct response. -0.4. In the year 2005, what is the difference between the Imports(as % of merchandise exports) in Barbados and Imports(as % of merchandise exports) in Gambia, The?
Give a very brief answer. 0.45. In the year 2005, what is the difference between the Imports(as % of merchandise exports) in Burundi and Imports(as % of merchandise exports) in Faeroe Islands?
Offer a terse response. -0.93. In the year 2005, what is the difference between the Imports(as % of merchandise exports) of Burundi and Imports(as % of merchandise exports) of Gambia, The?
Offer a terse response. -0.08. In the year 2005, what is the difference between the Imports(as % of merchandise exports) in Faeroe Islands and Imports(as % of merchandise exports) in Gambia, The?
Your answer should be compact. 0.85. In the year 2006, what is the difference between the Imports(as % of merchandise exports) in Barbados and Imports(as % of merchandise exports) in Burundi?
Give a very brief answer. 0.99. In the year 2006, what is the difference between the Imports(as % of merchandise exports) of Barbados and Imports(as % of merchandise exports) of Faeroe Islands?
Offer a very short reply. -1.02. In the year 2006, what is the difference between the Imports(as % of merchandise exports) of Barbados and Imports(as % of merchandise exports) of Gambia, The?
Provide a short and direct response. -0.09. In the year 2006, what is the difference between the Imports(as % of merchandise exports) in Burundi and Imports(as % of merchandise exports) in Faeroe Islands?
Offer a terse response. -2.01. In the year 2006, what is the difference between the Imports(as % of merchandise exports) of Burundi and Imports(as % of merchandise exports) of Gambia, The?
Provide a succinct answer. -1.08. In the year 2006, what is the difference between the Imports(as % of merchandise exports) of Faeroe Islands and Imports(as % of merchandise exports) of Gambia, The?
Provide a short and direct response. 0.93. In the year 2007, what is the difference between the Imports(as % of merchandise exports) in Barbados and Imports(as % of merchandise exports) in Burundi?
Your response must be concise. 1.73. In the year 2007, what is the difference between the Imports(as % of merchandise exports) in Barbados and Imports(as % of merchandise exports) in Faeroe Islands?
Offer a terse response. 0.35. In the year 2007, what is the difference between the Imports(as % of merchandise exports) of Barbados and Imports(as % of merchandise exports) of Gambia, The?
Provide a succinct answer. 0.69. In the year 2007, what is the difference between the Imports(as % of merchandise exports) in Burundi and Imports(as % of merchandise exports) in Faeroe Islands?
Your answer should be very brief. -1.38. In the year 2007, what is the difference between the Imports(as % of merchandise exports) of Burundi and Imports(as % of merchandise exports) of Gambia, The?
Your response must be concise. -1.04. In the year 2007, what is the difference between the Imports(as % of merchandise exports) in Faeroe Islands and Imports(as % of merchandise exports) in Gambia, The?
Provide a succinct answer. 0.34. In the year 2008, what is the difference between the Imports(as % of merchandise exports) in Barbados and Imports(as % of merchandise exports) in Burundi?
Your answer should be very brief. 0.15. In the year 2008, what is the difference between the Imports(as % of merchandise exports) of Barbados and Imports(as % of merchandise exports) of Faeroe Islands?
Your answer should be very brief. -0.13. In the year 2008, what is the difference between the Imports(as % of merchandise exports) in Barbados and Imports(as % of merchandise exports) in Gambia, The?
Your answer should be compact. -0.35. In the year 2008, what is the difference between the Imports(as % of merchandise exports) in Burundi and Imports(as % of merchandise exports) in Faeroe Islands?
Ensure brevity in your answer.  -0.28. In the year 2008, what is the difference between the Imports(as % of merchandise exports) in Burundi and Imports(as % of merchandise exports) in Gambia, The?
Provide a succinct answer. -0.5. In the year 2008, what is the difference between the Imports(as % of merchandise exports) of Faeroe Islands and Imports(as % of merchandise exports) of Gambia, The?
Offer a terse response. -0.22. What is the ratio of the Imports(as % of merchandise exports) in Barbados in 2001 to that in 2002?
Your answer should be compact. 0.88. What is the ratio of the Imports(as % of merchandise exports) in Burundi in 2001 to that in 2002?
Your answer should be compact. 1.03. What is the ratio of the Imports(as % of merchandise exports) of Faeroe Islands in 2001 to that in 2002?
Offer a very short reply. 1.05. What is the ratio of the Imports(as % of merchandise exports) of Gambia, The in 2001 to that in 2002?
Your response must be concise. 0.69. What is the ratio of the Imports(as % of merchandise exports) of Barbados in 2001 to that in 2003?
Your answer should be very brief. 1.17. What is the ratio of the Imports(as % of merchandise exports) in Burundi in 2001 to that in 2003?
Your answer should be compact. 1.94. What is the ratio of the Imports(as % of merchandise exports) in Faeroe Islands in 2001 to that in 2003?
Give a very brief answer. 1.1. What is the ratio of the Imports(as % of merchandise exports) of Gambia, The in 2001 to that in 2003?
Your response must be concise. 0.72. What is the ratio of the Imports(as % of merchandise exports) of Barbados in 2001 to that in 2004?
Offer a very short reply. 1.02. What is the ratio of the Imports(as % of merchandise exports) of Burundi in 2001 to that in 2004?
Offer a terse response. 2.21. What is the ratio of the Imports(as % of merchandise exports) of Faeroe Islands in 2001 to that in 2004?
Your answer should be compact. 0.86. What is the ratio of the Imports(as % of merchandise exports) in Gambia, The in 2001 to that in 2004?
Offer a very short reply. 0.83. What is the ratio of the Imports(as % of merchandise exports) of Barbados in 2001 to that in 2005?
Your response must be concise. 1.21. What is the ratio of the Imports(as % of merchandise exports) of Burundi in 2001 to that in 2005?
Your response must be concise. 1.87. What is the ratio of the Imports(as % of merchandise exports) in Faeroe Islands in 2001 to that in 2005?
Give a very brief answer. 1.2. What is the ratio of the Imports(as % of merchandise exports) in Gambia, The in 2001 to that in 2005?
Keep it short and to the point. 1.12. What is the ratio of the Imports(as % of merchandise exports) of Barbados in 2001 to that in 2006?
Provide a succinct answer. 1.12. What is the ratio of the Imports(as % of merchandise exports) of Burundi in 2001 to that in 2006?
Ensure brevity in your answer.  2.42. What is the ratio of the Imports(as % of merchandise exports) in Faeroe Islands in 2001 to that in 2006?
Offer a very short reply. 0.9. What is the ratio of the Imports(as % of merchandise exports) of Gambia, The in 2001 to that in 2006?
Give a very brief answer. 0.76. What is the ratio of the Imports(as % of merchandise exports) in Barbados in 2001 to that in 2007?
Give a very brief answer. 0.86. What is the ratio of the Imports(as % of merchandise exports) in Burundi in 2001 to that in 2007?
Ensure brevity in your answer.  2.81. What is the ratio of the Imports(as % of merchandise exports) in Faeroe Islands in 2001 to that in 2007?
Give a very brief answer. 1.21. What is the ratio of the Imports(as % of merchandise exports) in Gambia, The in 2001 to that in 2007?
Your answer should be very brief. 0.83. What is the ratio of the Imports(as % of merchandise exports) in Barbados in 2001 to that in 2008?
Provide a succinct answer. 1.31. What is the ratio of the Imports(as % of merchandise exports) in Burundi in 2001 to that in 2008?
Keep it short and to the point. 1.6. What is the ratio of the Imports(as % of merchandise exports) in Faeroe Islands in 2001 to that in 2008?
Give a very brief answer. 1.48. What is the ratio of the Imports(as % of merchandise exports) in Gambia, The in 2001 to that in 2008?
Provide a succinct answer. 0.77. What is the ratio of the Imports(as % of merchandise exports) of Barbados in 2002 to that in 2003?
Offer a terse response. 1.33. What is the ratio of the Imports(as % of merchandise exports) in Burundi in 2002 to that in 2003?
Make the answer very short. 1.88. What is the ratio of the Imports(as % of merchandise exports) in Faeroe Islands in 2002 to that in 2003?
Your answer should be compact. 1.04. What is the ratio of the Imports(as % of merchandise exports) of Gambia, The in 2002 to that in 2003?
Provide a short and direct response. 1.03. What is the ratio of the Imports(as % of merchandise exports) of Barbados in 2002 to that in 2004?
Make the answer very short. 1.16. What is the ratio of the Imports(as % of merchandise exports) in Burundi in 2002 to that in 2004?
Your answer should be compact. 2.15. What is the ratio of the Imports(as % of merchandise exports) in Faeroe Islands in 2002 to that in 2004?
Ensure brevity in your answer.  0.82. What is the ratio of the Imports(as % of merchandise exports) in Gambia, The in 2002 to that in 2004?
Keep it short and to the point. 1.2. What is the ratio of the Imports(as % of merchandise exports) of Barbados in 2002 to that in 2005?
Your response must be concise. 1.38. What is the ratio of the Imports(as % of merchandise exports) in Burundi in 2002 to that in 2005?
Ensure brevity in your answer.  1.81. What is the ratio of the Imports(as % of merchandise exports) in Faeroe Islands in 2002 to that in 2005?
Make the answer very short. 1.14. What is the ratio of the Imports(as % of merchandise exports) in Gambia, The in 2002 to that in 2005?
Make the answer very short. 1.62. What is the ratio of the Imports(as % of merchandise exports) of Barbados in 2002 to that in 2006?
Ensure brevity in your answer.  1.27. What is the ratio of the Imports(as % of merchandise exports) of Burundi in 2002 to that in 2006?
Provide a short and direct response. 2.35. What is the ratio of the Imports(as % of merchandise exports) of Faeroe Islands in 2002 to that in 2006?
Provide a succinct answer. 0.85. What is the ratio of the Imports(as % of merchandise exports) of Gambia, The in 2002 to that in 2006?
Your response must be concise. 1.09. What is the ratio of the Imports(as % of merchandise exports) of Barbados in 2002 to that in 2007?
Your answer should be very brief. 0.98. What is the ratio of the Imports(as % of merchandise exports) of Burundi in 2002 to that in 2007?
Your answer should be compact. 2.72. What is the ratio of the Imports(as % of merchandise exports) in Faeroe Islands in 2002 to that in 2007?
Make the answer very short. 1.14. What is the ratio of the Imports(as % of merchandise exports) of Gambia, The in 2002 to that in 2007?
Offer a very short reply. 1.19. What is the ratio of the Imports(as % of merchandise exports) in Barbados in 2002 to that in 2008?
Provide a short and direct response. 1.49. What is the ratio of the Imports(as % of merchandise exports) in Burundi in 2002 to that in 2008?
Offer a very short reply. 1.55. What is the ratio of the Imports(as % of merchandise exports) of Faeroe Islands in 2002 to that in 2008?
Your answer should be very brief. 1.4. What is the ratio of the Imports(as % of merchandise exports) of Gambia, The in 2002 to that in 2008?
Keep it short and to the point. 1.11. What is the ratio of the Imports(as % of merchandise exports) of Barbados in 2003 to that in 2004?
Offer a very short reply. 0.87. What is the ratio of the Imports(as % of merchandise exports) of Burundi in 2003 to that in 2004?
Give a very brief answer. 1.14. What is the ratio of the Imports(as % of merchandise exports) of Faeroe Islands in 2003 to that in 2004?
Your answer should be compact. 0.79. What is the ratio of the Imports(as % of merchandise exports) of Gambia, The in 2003 to that in 2004?
Provide a short and direct response. 1.16. What is the ratio of the Imports(as % of merchandise exports) in Barbados in 2003 to that in 2005?
Provide a short and direct response. 1.03. What is the ratio of the Imports(as % of merchandise exports) in Burundi in 2003 to that in 2005?
Offer a terse response. 0.96. What is the ratio of the Imports(as % of merchandise exports) in Faeroe Islands in 2003 to that in 2005?
Offer a terse response. 1.1. What is the ratio of the Imports(as % of merchandise exports) in Gambia, The in 2003 to that in 2005?
Make the answer very short. 1.57. What is the ratio of the Imports(as % of merchandise exports) of Barbados in 2003 to that in 2006?
Keep it short and to the point. 0.95. What is the ratio of the Imports(as % of merchandise exports) in Burundi in 2003 to that in 2006?
Your answer should be very brief. 1.25. What is the ratio of the Imports(as % of merchandise exports) of Faeroe Islands in 2003 to that in 2006?
Your answer should be compact. 0.82. What is the ratio of the Imports(as % of merchandise exports) in Gambia, The in 2003 to that in 2006?
Ensure brevity in your answer.  1.06. What is the ratio of the Imports(as % of merchandise exports) of Barbados in 2003 to that in 2007?
Provide a succinct answer. 0.74. What is the ratio of the Imports(as % of merchandise exports) in Burundi in 2003 to that in 2007?
Provide a succinct answer. 1.45. What is the ratio of the Imports(as % of merchandise exports) of Faeroe Islands in 2003 to that in 2007?
Your answer should be very brief. 1.1. What is the ratio of the Imports(as % of merchandise exports) of Gambia, The in 2003 to that in 2007?
Provide a succinct answer. 1.16. What is the ratio of the Imports(as % of merchandise exports) of Barbados in 2003 to that in 2008?
Your answer should be very brief. 1.12. What is the ratio of the Imports(as % of merchandise exports) in Burundi in 2003 to that in 2008?
Your answer should be very brief. 0.82. What is the ratio of the Imports(as % of merchandise exports) of Faeroe Islands in 2003 to that in 2008?
Ensure brevity in your answer.  1.34. What is the ratio of the Imports(as % of merchandise exports) of Gambia, The in 2003 to that in 2008?
Your answer should be very brief. 1.08. What is the ratio of the Imports(as % of merchandise exports) of Barbados in 2004 to that in 2005?
Your answer should be very brief. 1.19. What is the ratio of the Imports(as % of merchandise exports) in Burundi in 2004 to that in 2005?
Give a very brief answer. 0.84. What is the ratio of the Imports(as % of merchandise exports) in Faeroe Islands in 2004 to that in 2005?
Offer a very short reply. 1.39. What is the ratio of the Imports(as % of merchandise exports) in Gambia, The in 2004 to that in 2005?
Ensure brevity in your answer.  1.35. What is the ratio of the Imports(as % of merchandise exports) in Barbados in 2004 to that in 2006?
Provide a short and direct response. 1.1. What is the ratio of the Imports(as % of merchandise exports) in Burundi in 2004 to that in 2006?
Make the answer very short. 1.09. What is the ratio of the Imports(as % of merchandise exports) of Faeroe Islands in 2004 to that in 2006?
Offer a terse response. 1.04. What is the ratio of the Imports(as % of merchandise exports) in Gambia, The in 2004 to that in 2006?
Make the answer very short. 0.91. What is the ratio of the Imports(as % of merchandise exports) of Barbados in 2004 to that in 2007?
Your answer should be compact. 0.85. What is the ratio of the Imports(as % of merchandise exports) in Burundi in 2004 to that in 2007?
Keep it short and to the point. 1.27. What is the ratio of the Imports(as % of merchandise exports) of Faeroe Islands in 2004 to that in 2007?
Provide a succinct answer. 1.39. What is the ratio of the Imports(as % of merchandise exports) of Barbados in 2004 to that in 2008?
Provide a short and direct response. 1.29. What is the ratio of the Imports(as % of merchandise exports) of Burundi in 2004 to that in 2008?
Your answer should be compact. 0.72. What is the ratio of the Imports(as % of merchandise exports) in Faeroe Islands in 2004 to that in 2008?
Make the answer very short. 1.71. What is the ratio of the Imports(as % of merchandise exports) of Gambia, The in 2004 to that in 2008?
Keep it short and to the point. 0.93. What is the ratio of the Imports(as % of merchandise exports) of Barbados in 2005 to that in 2006?
Provide a short and direct response. 0.92. What is the ratio of the Imports(as % of merchandise exports) in Burundi in 2005 to that in 2006?
Provide a succinct answer. 1.29. What is the ratio of the Imports(as % of merchandise exports) of Faeroe Islands in 2005 to that in 2006?
Give a very brief answer. 0.75. What is the ratio of the Imports(as % of merchandise exports) of Gambia, The in 2005 to that in 2006?
Your answer should be very brief. 0.68. What is the ratio of the Imports(as % of merchandise exports) of Barbados in 2005 to that in 2007?
Your response must be concise. 0.71. What is the ratio of the Imports(as % of merchandise exports) in Burundi in 2005 to that in 2007?
Your answer should be compact. 1.5. What is the ratio of the Imports(as % of merchandise exports) of Gambia, The in 2005 to that in 2007?
Make the answer very short. 0.74. What is the ratio of the Imports(as % of merchandise exports) in Barbados in 2005 to that in 2008?
Your response must be concise. 1.08. What is the ratio of the Imports(as % of merchandise exports) in Burundi in 2005 to that in 2008?
Offer a very short reply. 0.85. What is the ratio of the Imports(as % of merchandise exports) of Faeroe Islands in 2005 to that in 2008?
Offer a terse response. 1.22. What is the ratio of the Imports(as % of merchandise exports) in Gambia, The in 2005 to that in 2008?
Your response must be concise. 0.69. What is the ratio of the Imports(as % of merchandise exports) in Barbados in 2006 to that in 2007?
Offer a very short reply. 0.77. What is the ratio of the Imports(as % of merchandise exports) of Burundi in 2006 to that in 2007?
Keep it short and to the point. 1.16. What is the ratio of the Imports(as % of merchandise exports) in Faeroe Islands in 2006 to that in 2007?
Offer a very short reply. 1.34. What is the ratio of the Imports(as % of merchandise exports) of Gambia, The in 2006 to that in 2007?
Your response must be concise. 1.09. What is the ratio of the Imports(as % of merchandise exports) of Barbados in 2006 to that in 2008?
Keep it short and to the point. 1.17. What is the ratio of the Imports(as % of merchandise exports) in Burundi in 2006 to that in 2008?
Your answer should be very brief. 0.66. What is the ratio of the Imports(as % of merchandise exports) in Faeroe Islands in 2006 to that in 2008?
Offer a very short reply. 1.64. What is the ratio of the Imports(as % of merchandise exports) in Gambia, The in 2006 to that in 2008?
Make the answer very short. 1.02. What is the ratio of the Imports(as % of merchandise exports) of Barbados in 2007 to that in 2008?
Offer a very short reply. 1.51. What is the ratio of the Imports(as % of merchandise exports) of Burundi in 2007 to that in 2008?
Your answer should be very brief. 0.57. What is the ratio of the Imports(as % of merchandise exports) in Faeroe Islands in 2007 to that in 2008?
Ensure brevity in your answer.  1.22. What is the ratio of the Imports(as % of merchandise exports) in Gambia, The in 2007 to that in 2008?
Offer a terse response. 0.93. What is the difference between the highest and the second highest Imports(as % of merchandise exports) of Barbados?
Your answer should be very brief. 0.04. What is the difference between the highest and the second highest Imports(as % of merchandise exports) in Burundi?
Provide a succinct answer. 0.08. What is the difference between the highest and the second highest Imports(as % of merchandise exports) of Faeroe Islands?
Make the answer very short. 0.13. What is the difference between the highest and the second highest Imports(as % of merchandise exports) in Gambia, The?
Your answer should be very brief. 0.07. What is the difference between the highest and the lowest Imports(as % of merchandise exports) of Barbados?
Offer a very short reply. 0.9. What is the difference between the highest and the lowest Imports(as % of merchandise exports) of Burundi?
Give a very brief answer. 1.63. What is the difference between the highest and the lowest Imports(as % of merchandise exports) in Faeroe Islands?
Your answer should be compact. 1.32. What is the difference between the highest and the lowest Imports(as % of merchandise exports) in Gambia, The?
Offer a very short reply. 0.89. 